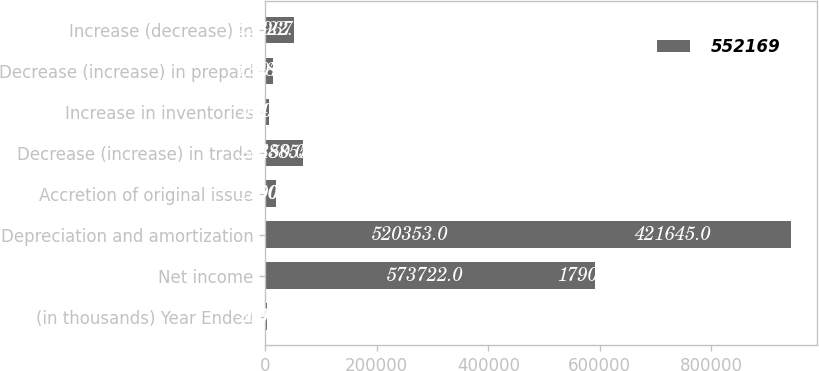Convert chart to OTSL. <chart><loc_0><loc_0><loc_500><loc_500><stacked_bar_chart><ecel><fcel>(in thousands) Year Ended<fcel>Net income<fcel>Depreciation and amortization<fcel>Accretion of original issue<fcel>Decrease (increase) in trade<fcel>Increase in inventories<fcel>Decrease (increase) in prepaid<fcel>Increase (decrease) in<nl><fcel>nan<fcel>2008<fcel>573722<fcel>520353<fcel>1750<fcel>28150<fcel>140<fcel>12884<fcel>22322<nl><fcel>552169<fcel>2006<fcel>17902<fcel>421645<fcel>17902<fcel>38855<fcel>7441<fcel>707<fcel>29671<nl></chart> 